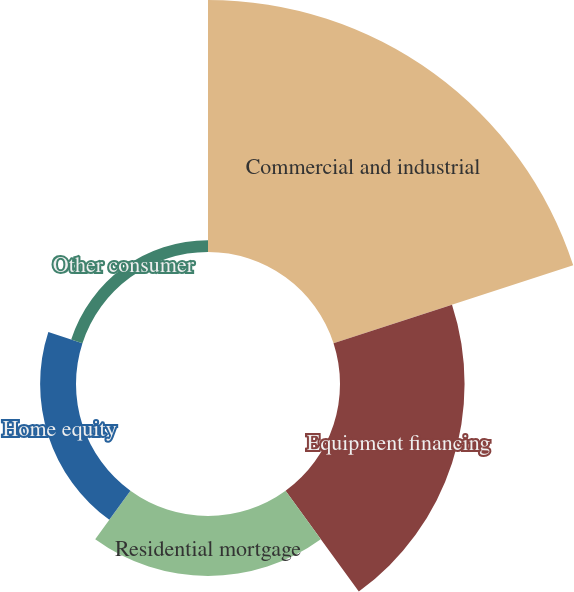Convert chart. <chart><loc_0><loc_0><loc_500><loc_500><pie_chart><fcel>Commercial and industrial<fcel>Equipment financing<fcel>Residential mortgage<fcel>Home equity<fcel>Other consumer<nl><fcel>52.05%<fcel>25.73%<fcel>12.37%<fcel>7.41%<fcel>2.45%<nl></chart> 